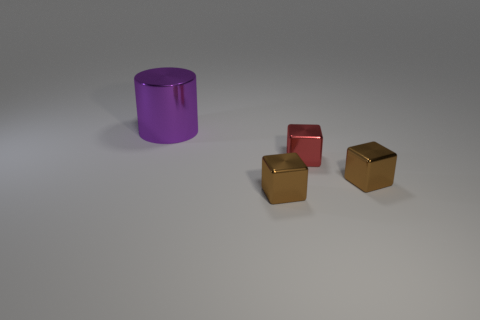Is there any other thing that has the same size as the metallic cylinder?
Make the answer very short. No. The small metal thing in front of the brown object that is to the right of the small red metallic block is what color?
Your answer should be compact. Brown. Are there any brown metallic spheres?
Offer a very short reply. No. Is the small red thing the same shape as the large thing?
Provide a short and direct response. No. How many brown metallic objects are on the right side of the brown shiny block that is left of the tiny red shiny thing?
Make the answer very short. 1. How many objects are behind the tiny red object and right of the purple object?
Your answer should be very brief. 0. How many objects are small objects or big purple shiny cylinders to the left of the tiny red metallic block?
Offer a very short reply. 4. What size is the red thing that is made of the same material as the large purple cylinder?
Give a very brief answer. Small. What is the shape of the small brown thing that is behind the brown shiny block to the left of the red cube?
Make the answer very short. Cube. How many red things are either cubes or metal cylinders?
Your response must be concise. 1. 